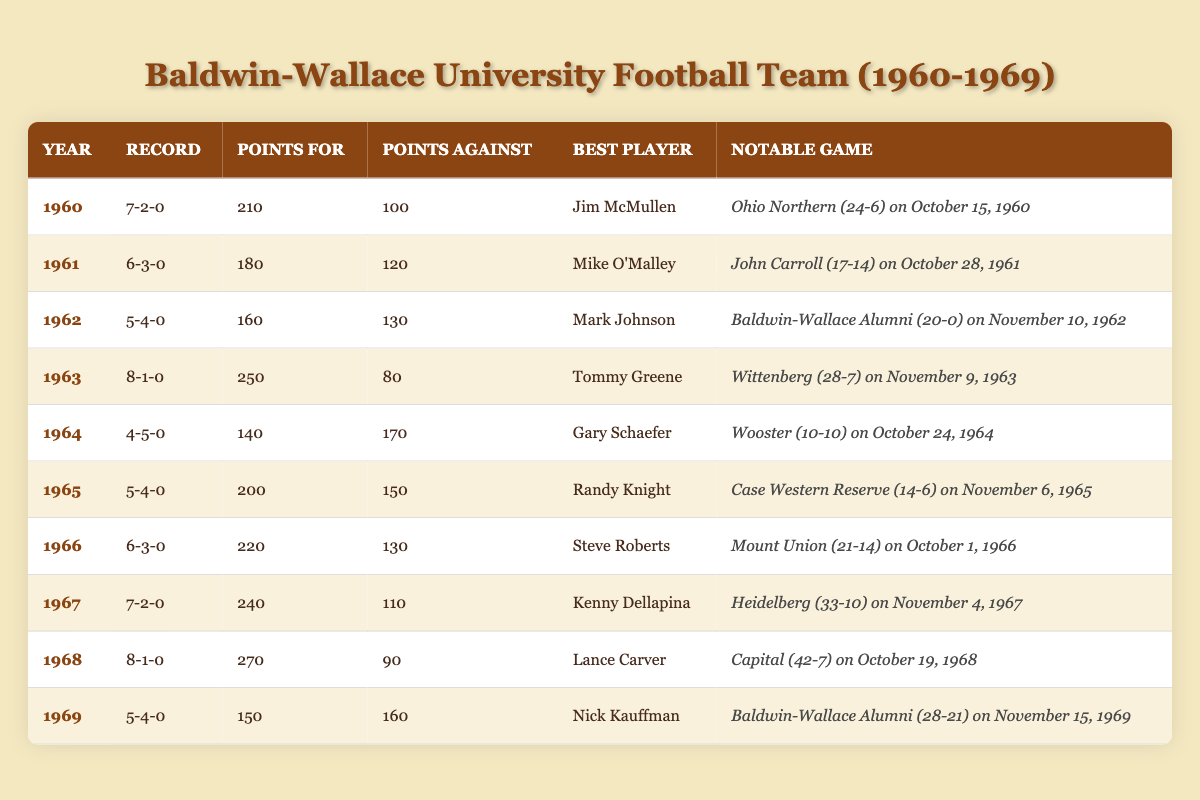What year did the Baldwin-Wallace University Football Team have the highest points scored? Looking at the table, 1968 shows the highest points scored at 270.
Answer: 1968 Which year had the lowest number of wins? The table shows that 1964 had the lowest number of wins with 4.
Answer: 1964 Did the team ever have a perfect winning season from 1960 to 1969? No, all seasons listed show at least one loss.
Answer: No What was the win-loss record for the year 1963? In 1963, the win-loss record was 8 wins and 1 loss, which can be seen directly in the record column for that year.
Answer: 8-1-0 Identify the year with the closest points scored against to points scored for. In 1969, the points scored for (150) and points against (160) are closest, with only a 10-point difference.
Answer: 1969 Which season's best player scored the most points for the team? In 1968, Lance Carver played during the season when the team scored the most points (270).
Answer: 1968 What was the average number of wins across all seasons from 1960 to 1969? Adding up all the wins (7 + 6 + 5 + 8 + 4 + 5 + 6 + 7 + 8 + 5) gives 57. Dividing by 10 (the number of seasons), the average is 57/10 = 5.7.
Answer: 5.7 In which year did the team score the fewest points? The table indicates that in 1964, the team scored the fewest points, totaling 140.
Answer: 1964 What was the notable game for the team during its best season? The best season was 1963, where the notable game was against Wittenberg with a score of 28-7.
Answer: Wittenberg (28-7) in 1963 How many total losses did the team have in the 1960s? By summing all the losses for each season (2 + 3 + 4 + 1 + 5 + 4 + 3 + 2 + 1 + 4), the total is 29 losses.
Answer: 29 Which player was recognized as the best player in the year 1966? The best player for 1966 is Steve Roberts, as shown in the corresponding row of the table.
Answer: Steve Roberts 